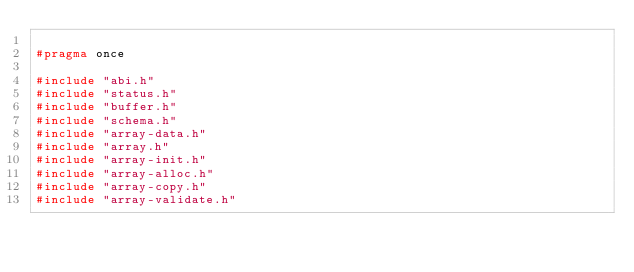<code> <loc_0><loc_0><loc_500><loc_500><_C_>
#pragma once

#include "abi.h"
#include "status.h"
#include "buffer.h"
#include "schema.h"
#include "array-data.h"
#include "array.h"
#include "array-init.h"
#include "array-alloc.h"
#include "array-copy.h"
#include "array-validate.h"
</code> 